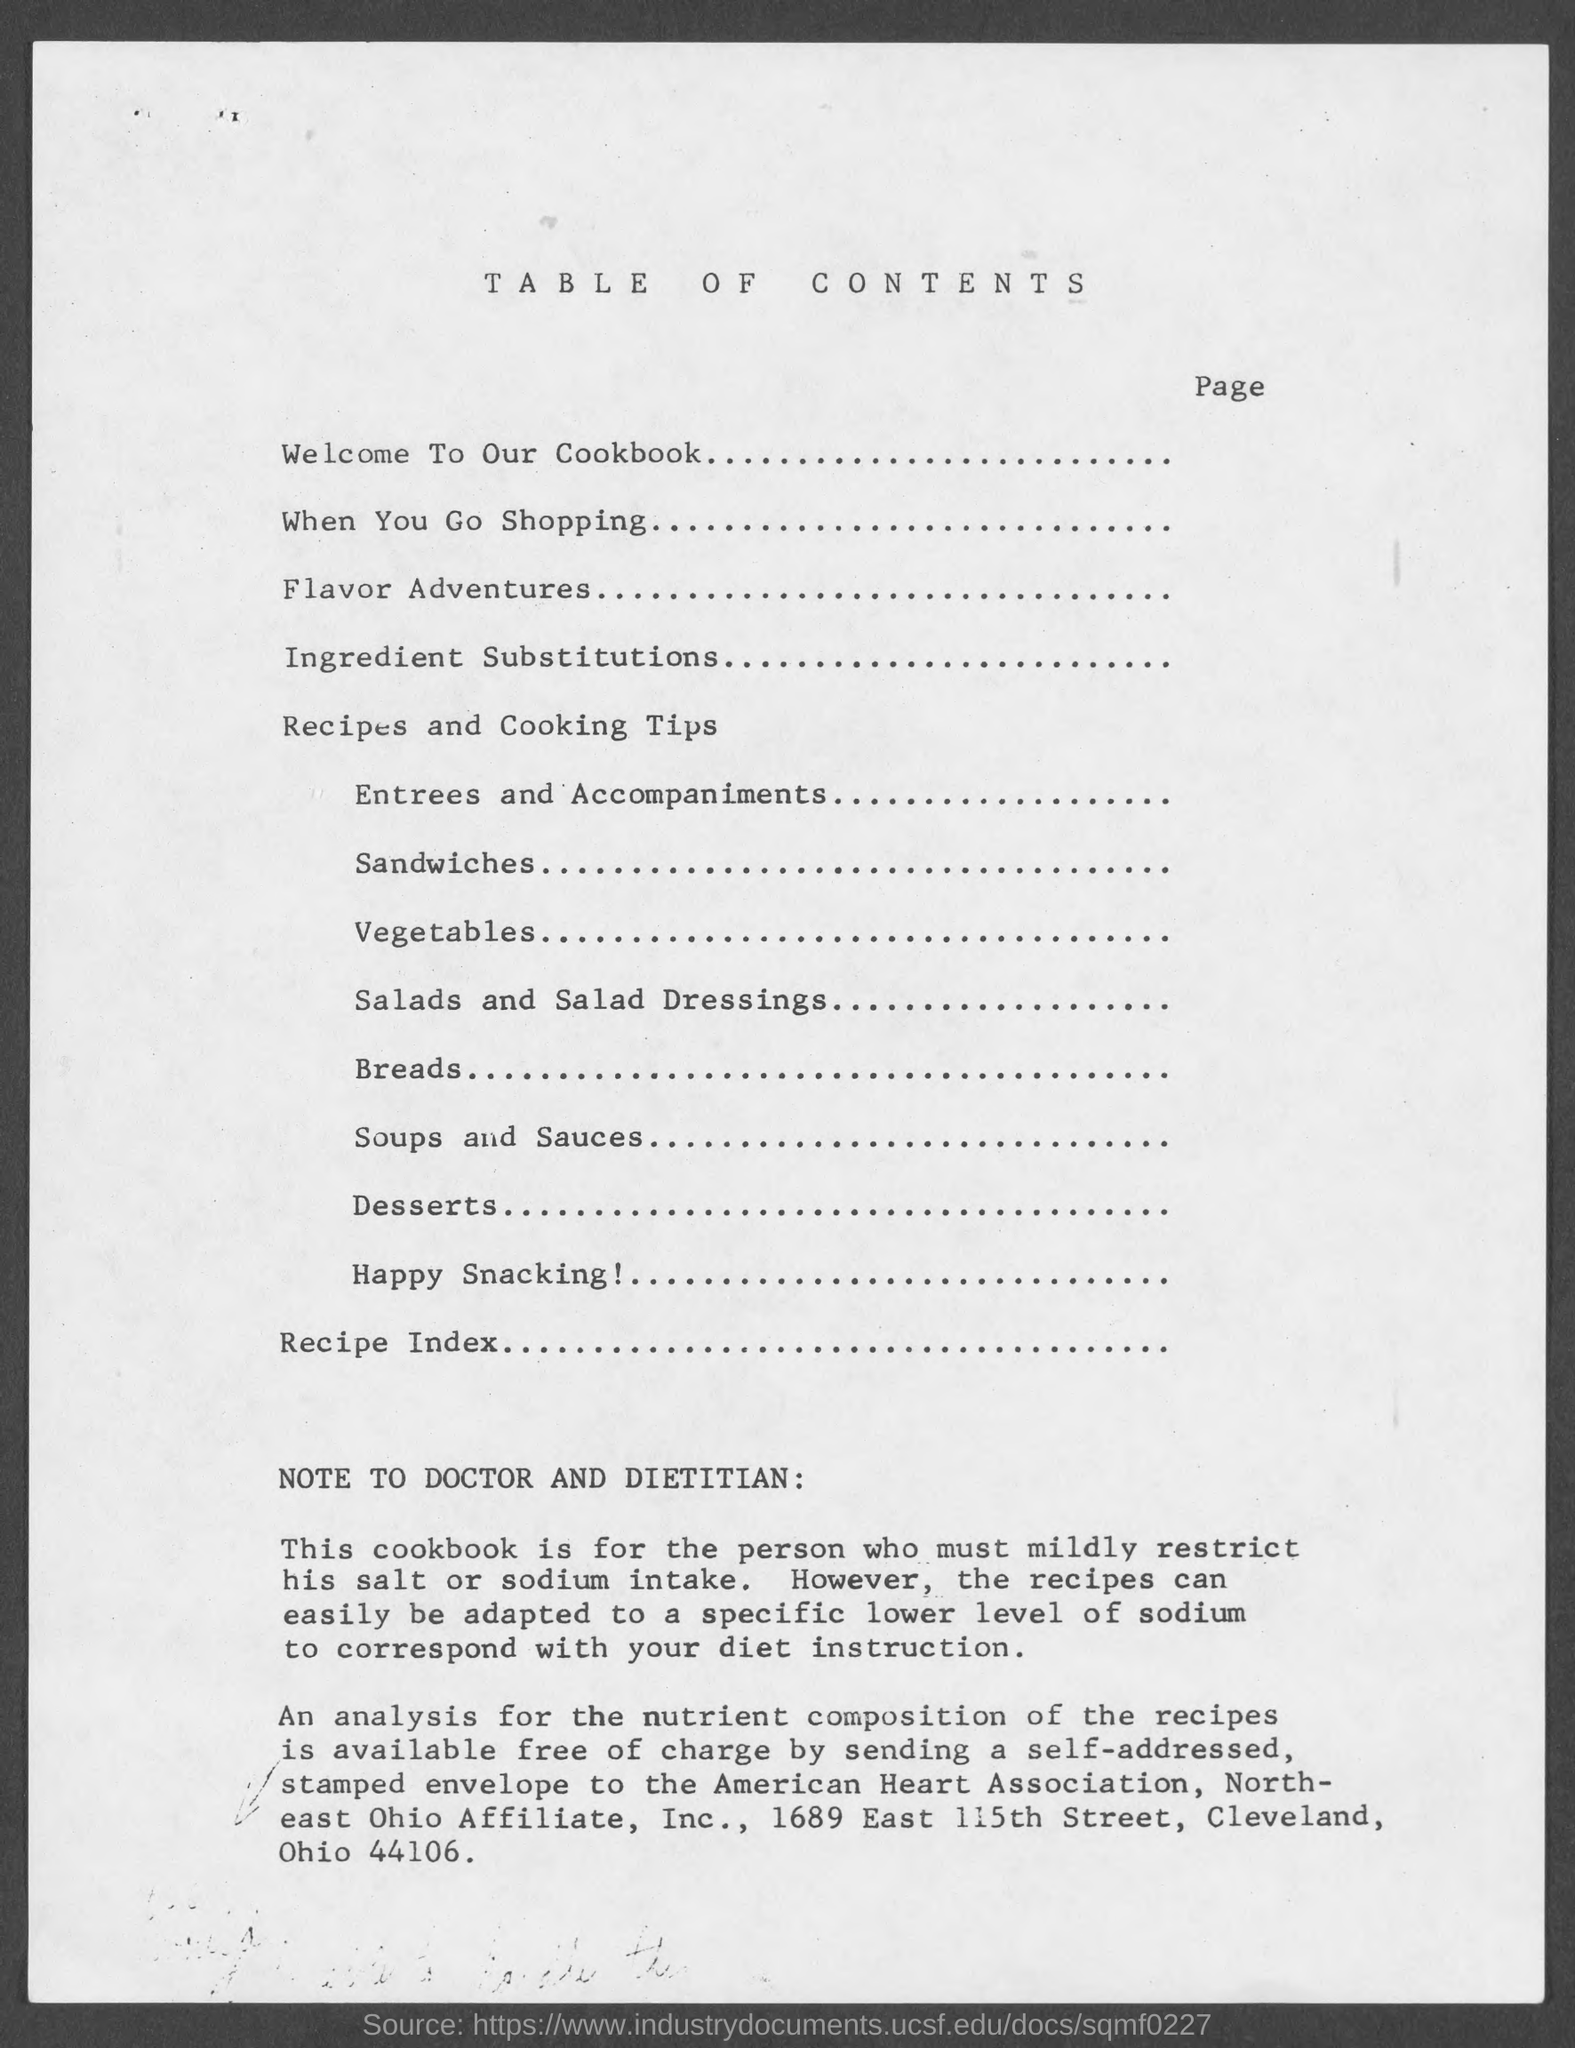Specify some key components in this picture. The second topic is when you go shopping. The third topic is Flavor Adventures, which focuses on exploring the world of flavors and discovering new tastes. The title of the document is [insert title] and it includes a table of contents [indicate whether the table of contents is included]. The first topic is Welcome to our Cookbook. 